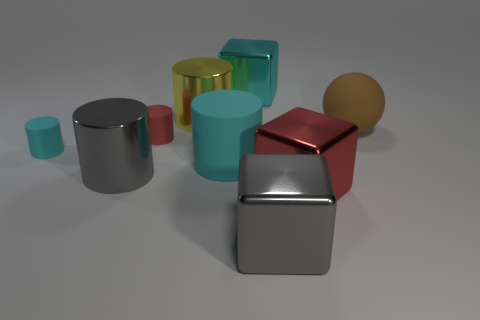Subtract all yellow cylinders. How many cylinders are left? 4 Subtract all large matte cylinders. How many cylinders are left? 4 Subtract all purple cylinders. Subtract all red blocks. How many cylinders are left? 5 Subtract all spheres. How many objects are left? 8 Subtract all brown rubber balls. Subtract all brown spheres. How many objects are left? 7 Add 8 large gray shiny cylinders. How many large gray shiny cylinders are left? 9 Add 4 green matte cylinders. How many green matte cylinders exist? 4 Subtract 1 cyan cylinders. How many objects are left? 8 